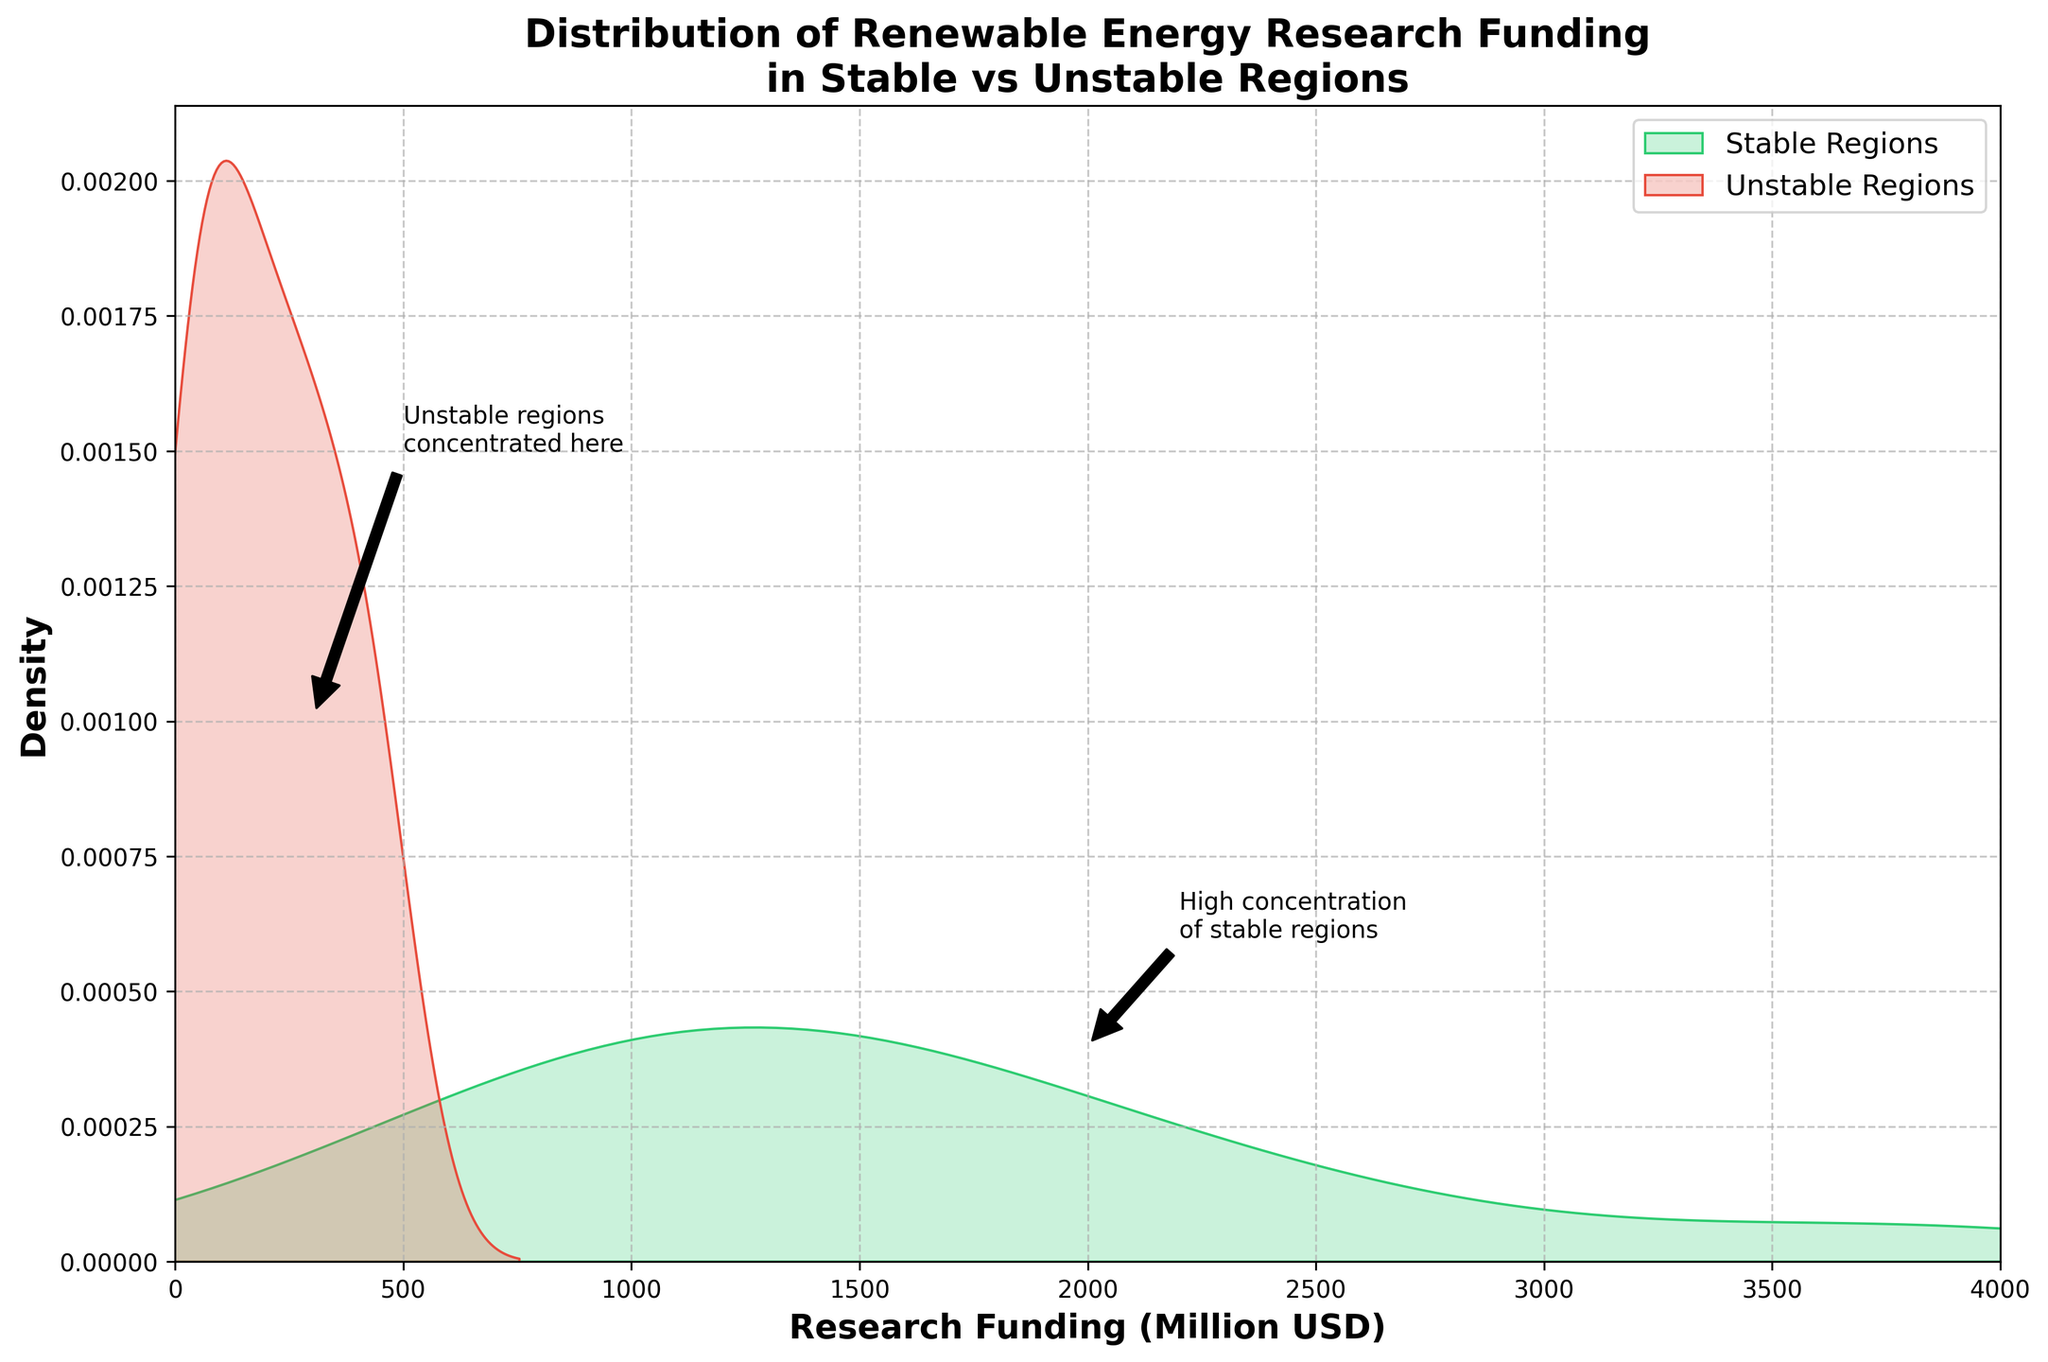what is the title of the figure? The title of the figure is displayed at the top and describes the focus of the plot.
Answer: Distribution of Renewable Energy Research Funding in Stable vs Unstable Regions How many density lines are plotted on the figure? There are two distinct density lines with different colors, representing the stable and unstable regions.
Answer: Two What are the colors used for stable and unstable regions in the density plot? The colors can be identified by looking at the plot legends. The curve for stable regions is green and for unstable regions, it is red.
Answer: Green (Stable Regions) and Red (Unstable Regions) What is the range for the research funding on the x-axis? The range for the research funding is specified along the x-axis of the graph, starting at 0 and ending at 4000 million USD.
Answer: 0 to 4000 million USD Where do unstable regions' research funding densities peak approximately? The density peaks for unstable regions can be observed around the highest concentration point on their curve.
Answer: Around 300 million USD Between which funding amounts are the annotations for "High concentration of stable regions" and "Unstable regions concentrated here"? The annotations indicate specific points of interest. The high concentration of stable regions is annotated around 2000 million USD, while the concentration of unstable regions is around 300 million USD.
Answer: 2000 million USD for stable regions; 300 million USD for unstable regions Which region shows higher concentration at lower funding levels? Stable or unstable? By comparing the density curves, the red curve (unstable regions) shows a higher concentration at lower funding levels.
Answer: Unstable regions Approximately where does the density for stable regions start to decline significantly? The density curve for stable regions starts to decline significantly after its highest peak point, moving towards the right on the x-axis.
Answer: After 2000 million USD Can you infer any correlation between political stability and average research funding in renewable energy? By observing the density peaks and spread, stable regions tend to have higher average funding as indicated by their peak around higher funding amounts and spread.
Answer: Higher funding in stable regions What can you deduce from the width of the density peak for stable regions compared to unstable regions? The width of the density peaks indicates the spread of the funding amounts. The peak for stable regions is wider, suggesting a broader distribution across different funding levels.
Answer: Broader spread in stable regions 